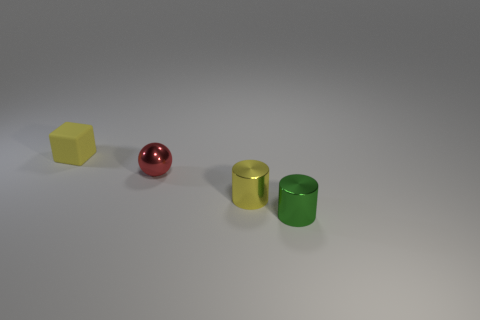There is an object that is the same color as the tiny matte cube; what size is it? The object sharing the same color as the tiny matte cube is a small sphere. Like the cube, it has a subtle, non-reflective surface which is indicative of its matte finish. 